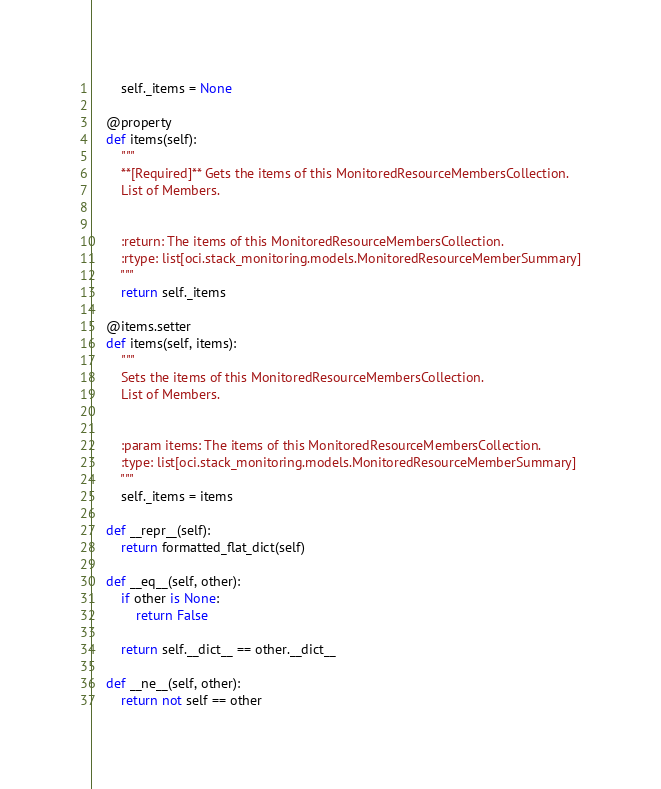<code> <loc_0><loc_0><loc_500><loc_500><_Python_>
        self._items = None

    @property
    def items(self):
        """
        **[Required]** Gets the items of this MonitoredResourceMembersCollection.
        List of Members.


        :return: The items of this MonitoredResourceMembersCollection.
        :rtype: list[oci.stack_monitoring.models.MonitoredResourceMemberSummary]
        """
        return self._items

    @items.setter
    def items(self, items):
        """
        Sets the items of this MonitoredResourceMembersCollection.
        List of Members.


        :param items: The items of this MonitoredResourceMembersCollection.
        :type: list[oci.stack_monitoring.models.MonitoredResourceMemberSummary]
        """
        self._items = items

    def __repr__(self):
        return formatted_flat_dict(self)

    def __eq__(self, other):
        if other is None:
            return False

        return self.__dict__ == other.__dict__

    def __ne__(self, other):
        return not self == other
</code> 